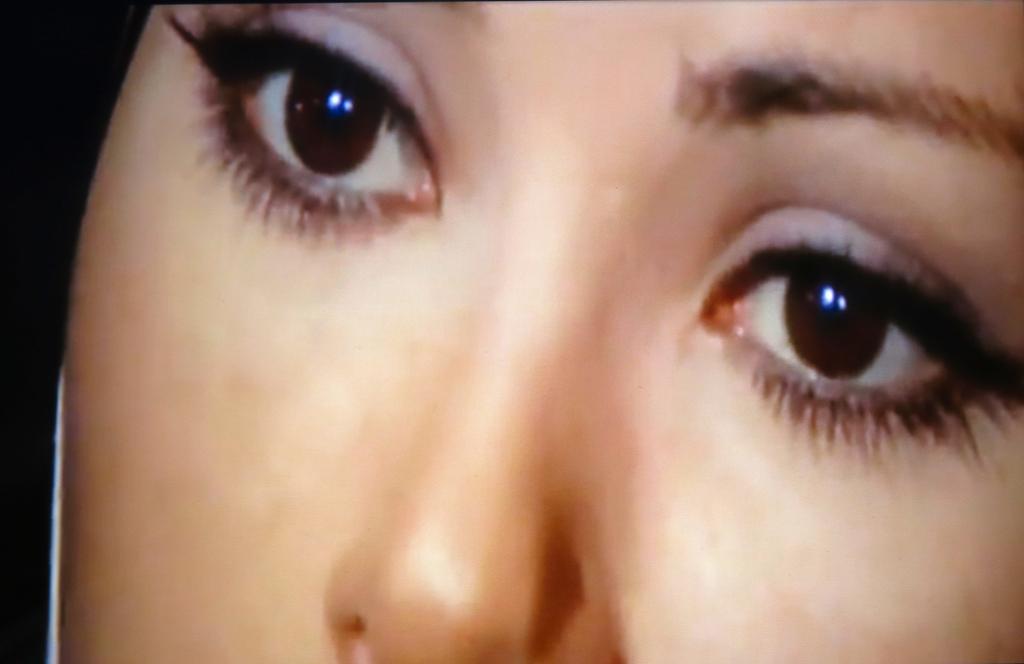Can you describe this image briefly? In this picture we can see a person face, eyes and nose. On the left side, the image is dark. 